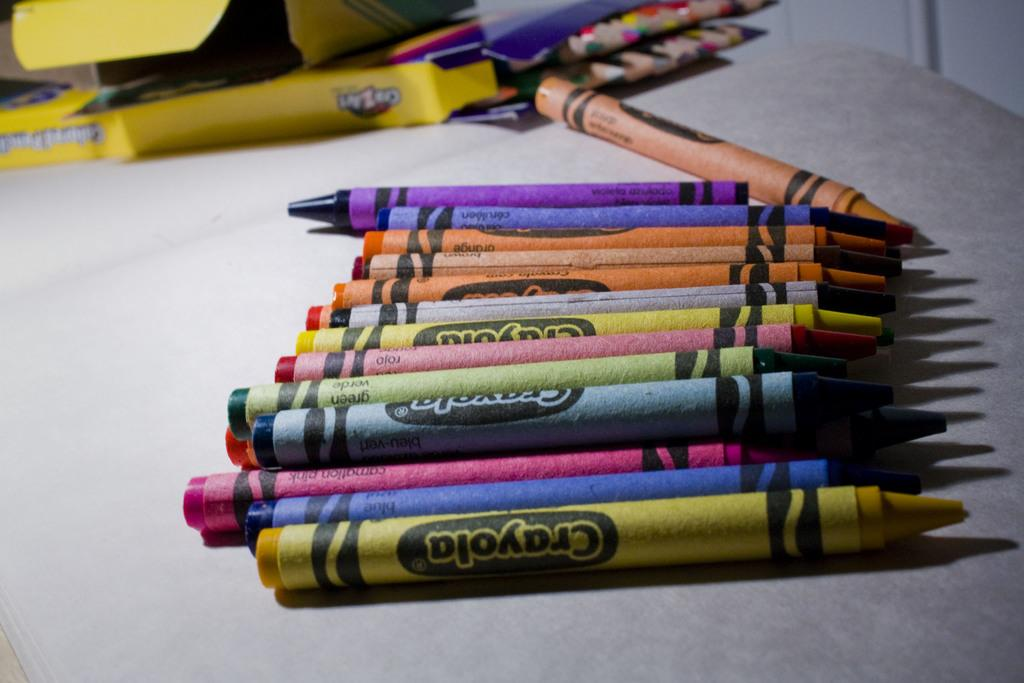<image>
Offer a succinct explanation of the picture presented. A bunch of different colors are available with Crayola crayons. 